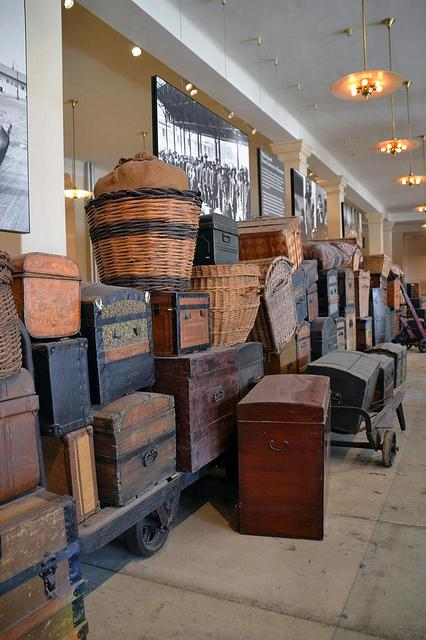What are the largest rectangular clothing item storage pieces called? trunks 